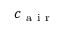<formula> <loc_0><loc_0><loc_500><loc_500>c _ { a i r }</formula> 